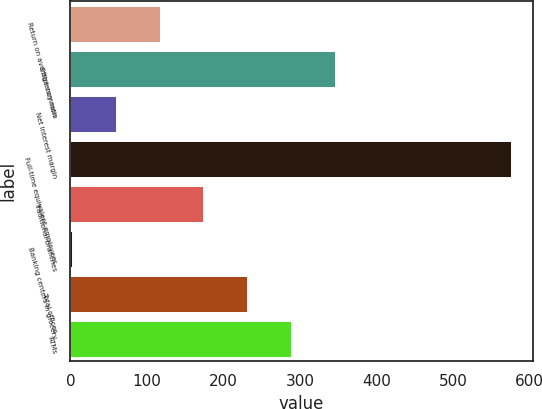<chart> <loc_0><loc_0><loc_500><loc_500><bar_chart><fcel>Return on average common<fcel>Efficiency ratio<fcel>Net interest margin<fcel>Full-time equivalent employees<fcel>Traditional branches<fcel>Banking centers in grocery<fcel>Total offices<fcel>ATMs<nl><fcel>116.6<fcel>345.8<fcel>59.3<fcel>575<fcel>173.9<fcel>2<fcel>231.2<fcel>288.5<nl></chart> 